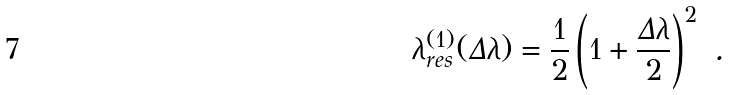Convert formula to latex. <formula><loc_0><loc_0><loc_500><loc_500>\lambda ^ { ( 1 ) } _ { r e s } ( \Delta \lambda ) = \frac { 1 } { 2 } \left ( 1 + \frac { \Delta \lambda } { 2 } \right ) ^ { 2 } \ .</formula> 